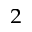<formula> <loc_0><loc_0><loc_500><loc_500>_ { 2 }</formula> 